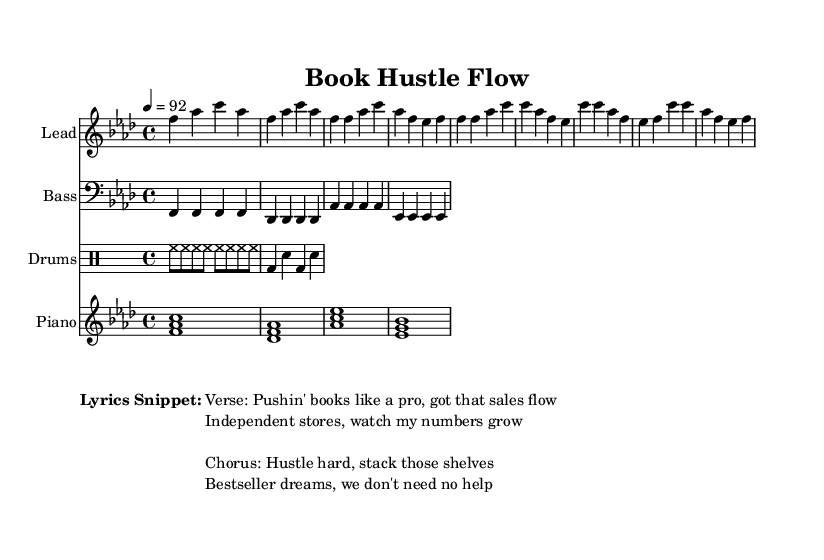What is the key signature of this music? The key signature is F minor, which has four flats (B, E, A, and D). This can be identified from the key signature notation in the beginning of the score.
Answer: F minor What is the time signature of this music? The time signature is 4/4, indicating that there are four beats in each measure and the quarter note gets one beat. This is also clearly indicated at the beginning of the music.
Answer: 4/4 What is the tempo marking for this music? The tempo marking is 92 beats per minute, which can be found in the tempo indication (4 = 92) at the beginning of the score.
Answer: 92 What instrument is playing the lead part? The lead part is played by a synthesizer, identified in the score by the label "Lead" above the staff.
Answer: Lead How many measures are present in the lead synth part? There are a total of eight measures in the lead synth part, which can be counted by looking at the measures in the notated section.
Answer: Eight What is the primary theme of the lyrics in this sheet music? The main theme centers around the hustle of selling books and striving for success, as indicated in the lyrics snippet provided. The lyrics emphasize working hard and achieving bestseller status.
Answer: Sales hustle What kind of rhythmic pattern does the drums part primarily use? The drums part uses a consistent pattern of high-hat and bass drum hits, establishing a driving rhythm typical in hip hop music, focusing on repeated eighth notes for the high-hat and alternating between bass and snare drum hits.
Answer: Eighth notes 